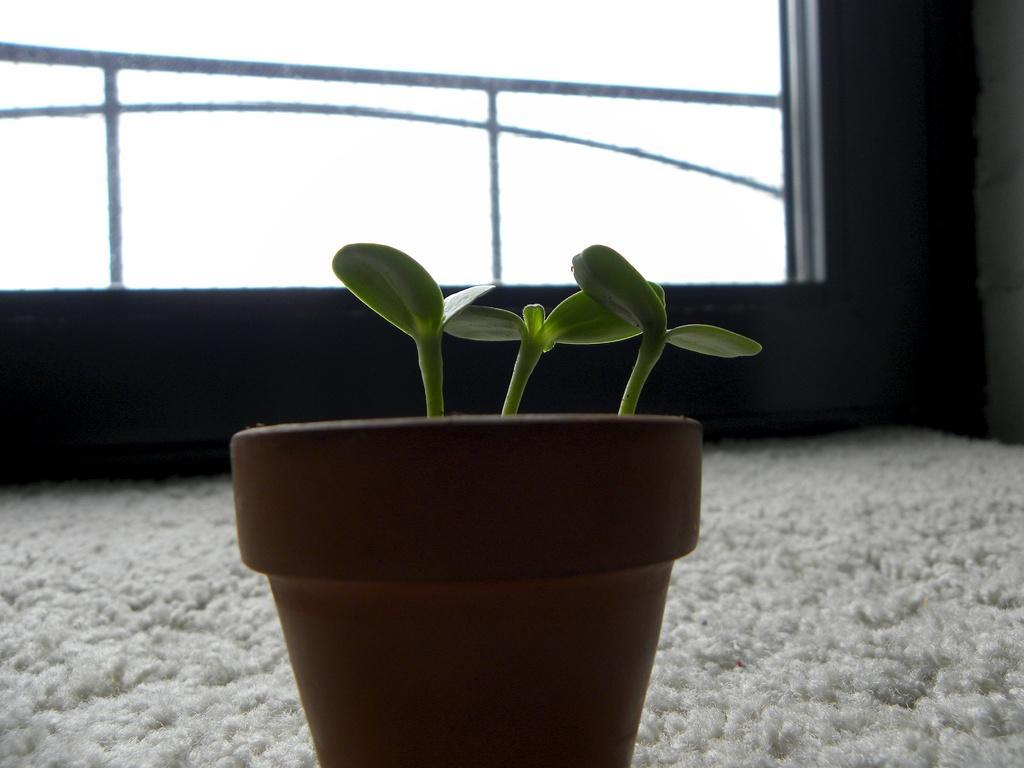Describe this image in one or two sentences. In this image we can see a plant in a flower pot. At the bottom of the image there is carpet. In the background of the image there is wall. There is a railing. 